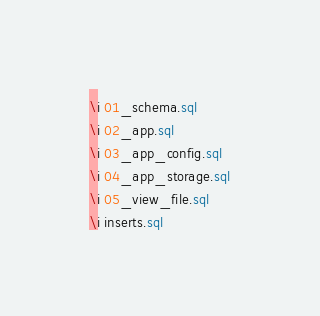Convert code to text. <code><loc_0><loc_0><loc_500><loc_500><_SQL_>\i 01_schema.sql
\i 02_app.sql
\i 03_app_config.sql
\i 04_app_storage.sql
\i 05_view_file.sql
\i inserts.sql
</code> 